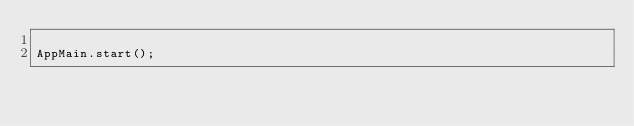Convert code to text. <code><loc_0><loc_0><loc_500><loc_500><_JavaScript_>
AppMain.start();
</code> 